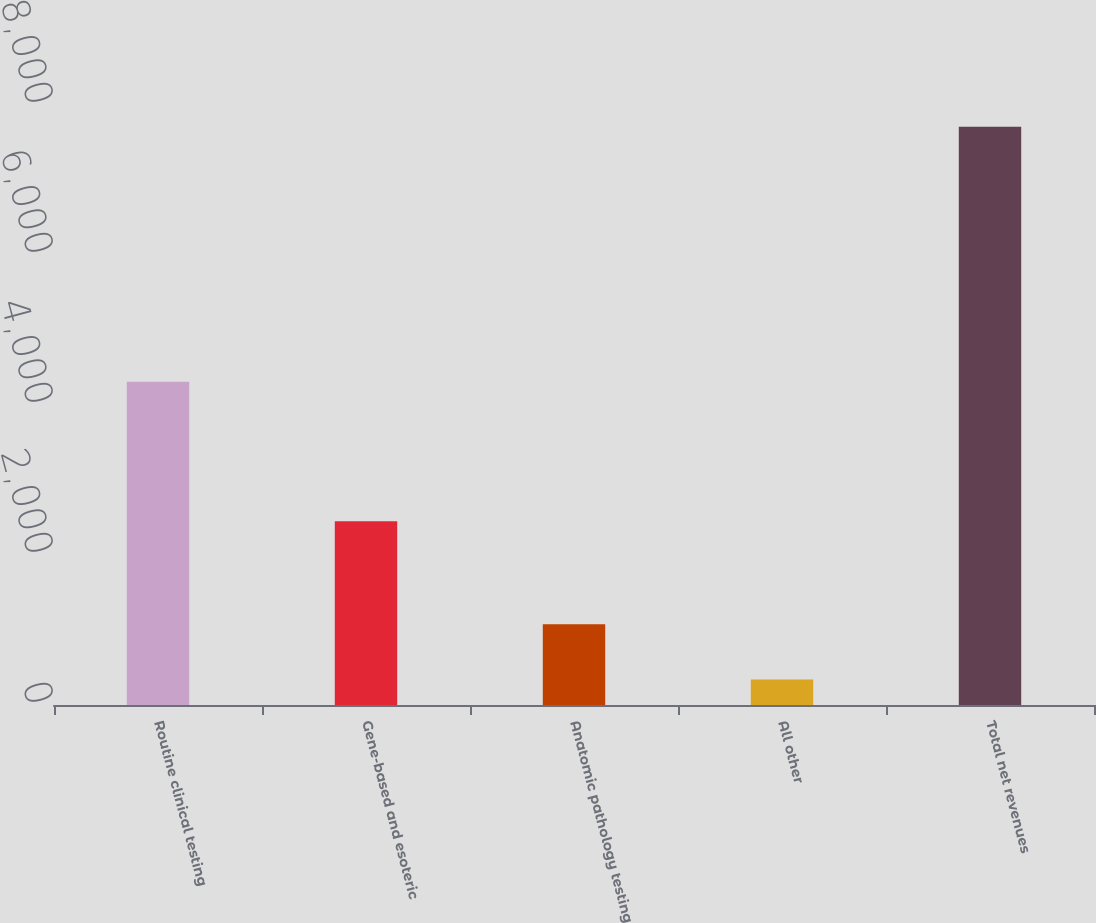Convert chart to OTSL. <chart><loc_0><loc_0><loc_500><loc_500><bar_chart><fcel>Routine clinical testing<fcel>Gene-based and esoteric<fcel>Anatomic pathology testing<fcel>All other<fcel>Total net revenues<nl><fcel>4309<fcel>2449<fcel>1076<fcel>339<fcel>7709<nl></chart> 